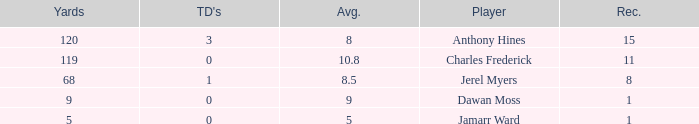What is the total Avg when TDs are 0 and Dawan Moss is a player? 0.0. 